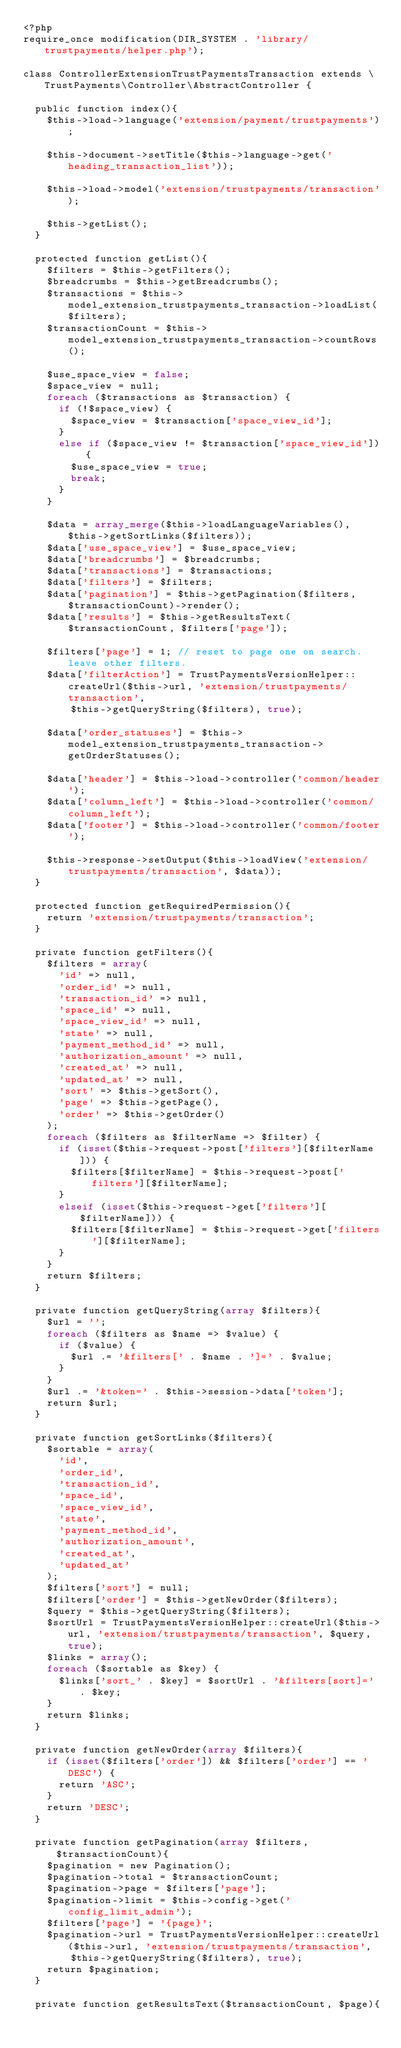Convert code to text. <code><loc_0><loc_0><loc_500><loc_500><_PHP_><?php
require_once modification(DIR_SYSTEM . 'library/trustpayments/helper.php');

class ControllerExtensionTrustPaymentsTransaction extends \TrustPayments\Controller\AbstractController {

	public function index(){
		$this->load->language('extension/payment/trustpayments');
		
		$this->document->setTitle($this->language->get('heading_transaction_list'));
		
		$this->load->model('extension/trustpayments/transaction');
		
		$this->getList();
	}

	protected function getList(){
		$filters = $this->getFilters();
		$breadcrumbs = $this->getBreadcrumbs();
		$transactions = $this->model_extension_trustpayments_transaction->loadList($filters);
		$transactionCount = $this->model_extension_trustpayments_transaction->countRows();
		
		$use_space_view = false;
		$space_view = null;
		foreach ($transactions as $transaction) {
			if (!$space_view) {
				$space_view = $transaction['space_view_id'];
			}
			else if ($space_view != $transaction['space_view_id']) {
				$use_space_view = true;
				break;
			}
		}
		
		$data = array_merge($this->loadLanguageVariables(), $this->getSortLinks($filters));
		$data['use_space_view'] = $use_space_view;
		$data['breadcrumbs'] = $breadcrumbs;
		$data['transactions'] = $transactions;
		$data['filters'] = $filters;
		$data['pagination'] = $this->getPagination($filters, $transactionCount)->render();
		$data['results'] = $this->getResultsText($transactionCount, $filters['page']);
		
		$filters['page'] = 1; // reset to page one on search. leave other filters.
		$data['filterAction'] = TrustPaymentsVersionHelper::createUrl($this->url, 'extension/trustpayments/transaction',
				$this->getQueryString($filters), true);
		
		$data['order_statuses'] = $this->model_extension_trustpayments_transaction->getOrderStatuses();
		
		$data['header'] = $this->load->controller('common/header');
		$data['column_left'] = $this->load->controller('common/column_left');
		$data['footer'] = $this->load->controller('common/footer');
		
		$this->response->setOutput($this->loadView('extension/trustpayments/transaction', $data));
	}

	protected function getRequiredPermission(){
		return 'extension/trustpayments/transaction';
	}

	private function getFilters(){
		$filters = array(
			'id' => null,
			'order_id' => null,
			'transaction_id' => null,
			'space_id' => null,
			'space_view_id' => null,
			'state' => null,
			'payment_method_id' => null,
			'authorization_amount' => null,
			'created_at' => null,
			'updated_at' => null,
			'sort' => $this->getSort(),
			'page' => $this->getPage(),
			'order' => $this->getOrder() 
		);
		foreach ($filters as $filterName => $filter) {
			if (isset($this->request->post['filters'][$filterName])) {
				$filters[$filterName] = $this->request->post['filters'][$filterName];
			}
			elseif (isset($this->request->get['filters'][$filterName])) {
				$filters[$filterName] = $this->request->get['filters'][$filterName];
			}
		}
		return $filters;
	}

	private function getQueryString(array $filters){
		$url = '';
		foreach ($filters as $name => $value) {
			if ($value) {
				$url .= '&filters[' . $name . ']=' . $value;
			}
		}
		$url .= '&token=' . $this->session->data['token'];
		return $url;
	}

	private function getSortLinks($filters){
		$sortable = array(
			'id',
			'order_id',
			'transaction_id',
			'space_id',
			'space_view_id',
			'state',
			'payment_method_id',
			'authorization_amount',
			'created_at',
			'updated_at' 
		);
		$filters['sort'] = null;
		$filters['order'] = $this->getNewOrder($filters);
		$query = $this->getQueryString($filters);
		$sortUrl = TrustPaymentsVersionHelper::createUrl($this->url, 'extension/trustpayments/transaction', $query, true);
		$links = array();
		foreach ($sortable as $key) {
			$links['sort_' . $key] = $sortUrl . '&filters[sort]=' . $key;
		}
		return $links;
	}

	private function getNewOrder(array $filters){
		if (isset($filters['order']) && $filters['order'] == 'DESC') {
			return 'ASC';
		}
		return 'DESC';
	}

	private function getPagination(array $filters, $transactionCount){
		$pagination = new Pagination();
		$pagination->total = $transactionCount;
		$pagination->page = $filters['page'];
		$pagination->limit = $this->config->get('config_limit_admin');
		$filters['page'] = '{page}';
		$pagination->url = TrustPaymentsVersionHelper::createUrl($this->url, 'extension/trustpayments/transaction',
				$this->getQueryString($filters), true);
		return $pagination;
	}

	private function getResultsText($transactionCount, $page){</code> 